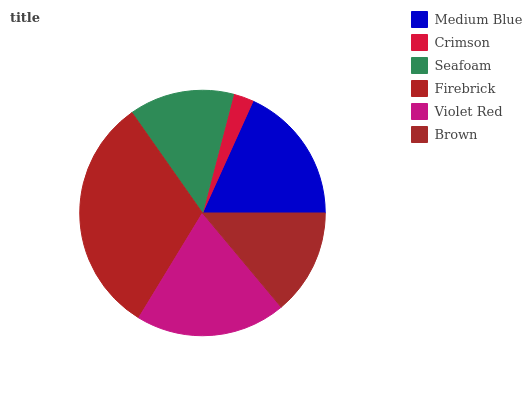Is Crimson the minimum?
Answer yes or no. Yes. Is Firebrick the maximum?
Answer yes or no. Yes. Is Seafoam the minimum?
Answer yes or no. No. Is Seafoam the maximum?
Answer yes or no. No. Is Seafoam greater than Crimson?
Answer yes or no. Yes. Is Crimson less than Seafoam?
Answer yes or no. Yes. Is Crimson greater than Seafoam?
Answer yes or no. No. Is Seafoam less than Crimson?
Answer yes or no. No. Is Medium Blue the high median?
Answer yes or no. Yes. Is Brown the low median?
Answer yes or no. Yes. Is Firebrick the high median?
Answer yes or no. No. Is Medium Blue the low median?
Answer yes or no. No. 